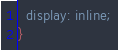Convert code to text. <code><loc_0><loc_0><loc_500><loc_500><_CSS_>  display: inline;
}
</code> 